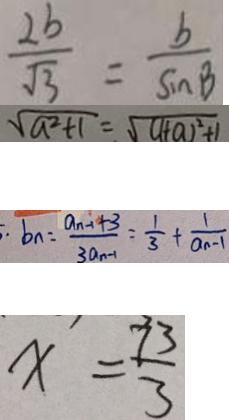<formula> <loc_0><loc_0><loc_500><loc_500>\frac { 2 b } { \sqrt { 3 } } = \frac { b } { \sin B } 
 \sqrt { a ^ { 2 } + 1 } = \sqrt { ( 1 + a ) ^ { 2 } + 1 } 
 \cdot b _ { n } = \frac { a _ { n - 1 } + 3 } { 3 a _ { n - 1 } } = \frac { 1 } { 3 } + \frac { 1 } { a _ { n - 1 } } 
 x = \frac { 7 3 } { 3 }</formula> 